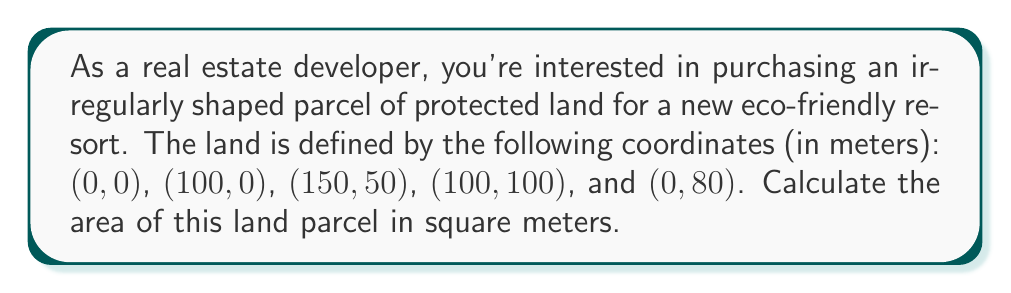Can you answer this question? To calculate the area of an irregularly shaped land parcel using coordinate geometry, we can use the Shoelace formula (also known as the surveyor's formula). This method involves the following steps:

1. List the coordinates in order, repeating the first coordinate at the end.
2. Multiply each x-coordinate by the next y-coordinate.
3. Multiply each y-coordinate by the next x-coordinate.
4. Subtract the sum of the second products from the sum of the first products.
5. Take the absolute value of the result and divide by 2.

Let's apply this to our coordinates:

$$(x_1, y_1) = (0, 0)$$
$$(x_2, y_2) = (100, 0)$$
$$(x_3, y_3) = (150, 50)$$
$$(x_4, y_4) = (100, 100)$$
$$(x_5, y_5) = (0, 80)$$

Repeating the first coordinate: $$(x_6, y_6) = (0, 0)$$

Now, let's apply the formula:

$$\text{Area} = \frac{1}{2}|(x_1y_2 + x_2y_3 + x_3y_4 + x_4y_5 + x_5y_6) - (y_1x_2 + y_2x_3 + y_3x_4 + y_4x_5 + y_5x_6)|$$

Substituting the values:

$$\begin{align*}
\text{Area} &= \frac{1}{2}|(0 \cdot 0 + 100 \cdot 50 + 150 \cdot 100 + 100 \cdot 80 + 0 \cdot 0) \\
&\quad - (0 \cdot 100 + 0 \cdot 150 + 50 \cdot 100 + 100 \cdot 0 + 80 \cdot 0)|
\end{align*}$$

$$\begin{align*}
\text{Area} &= \frac{1}{2}|(5000 + 15000 + 8000) - (5000)|
\end{align*}$$

$$\begin{align*}
\text{Area} &= \frac{1}{2}|28000 - 5000|
\end{align*}$$

$$\begin{align*}
\text{Area} &= \frac{1}{2}|23000|
\end{align*}$$

$$\text{Area} = 11500$$

Therefore, the area of the irregularly shaped land parcel is 11,500 square meters.

[asy]
unitsize(0.05cm);
draw((0,0)--(100,0)--(150,50)--(100,100)--(0,80)--cycle);
label("(0,0)", (0,0), SW);
label("(100,0)", (100,0), SE);
label("(150,50)", (150,50), E);
label("(100,100)", (100,100), NE);
label("(0,80)", (0,80), NW);
[/asy]
Answer: The area of the irregularly shaped land parcel is 11,500 square meters. 